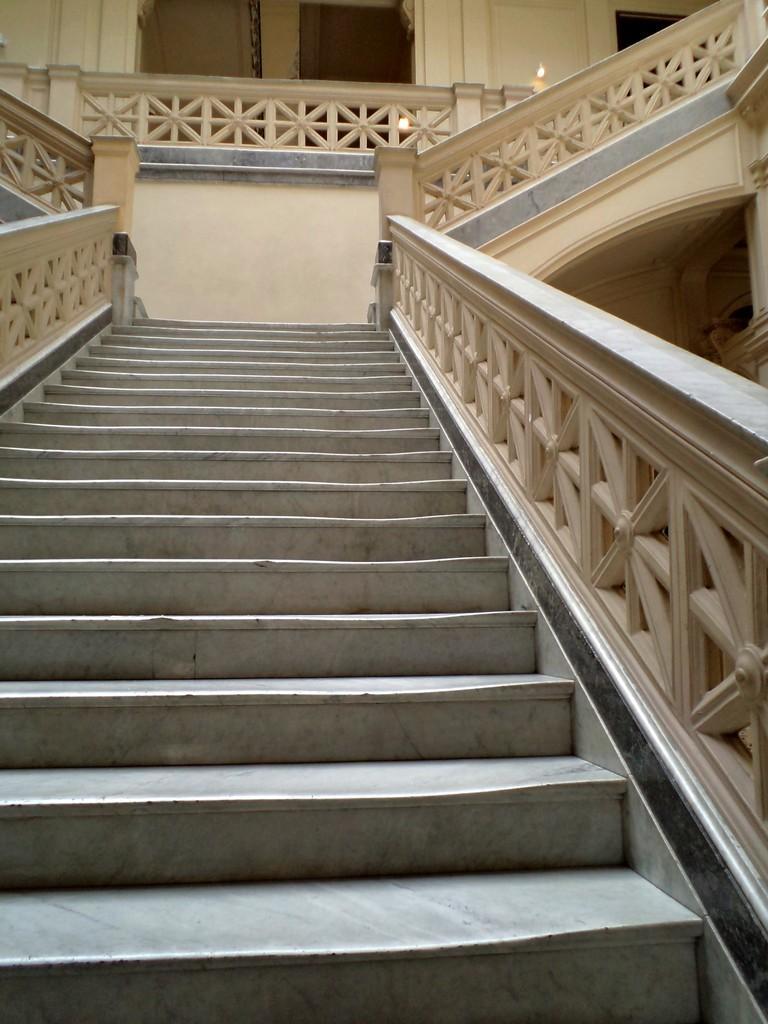Please provide a concise description of this image. In the center of the image we can see staircase, staircase railing. In the background of the image there is door. There is wall. 